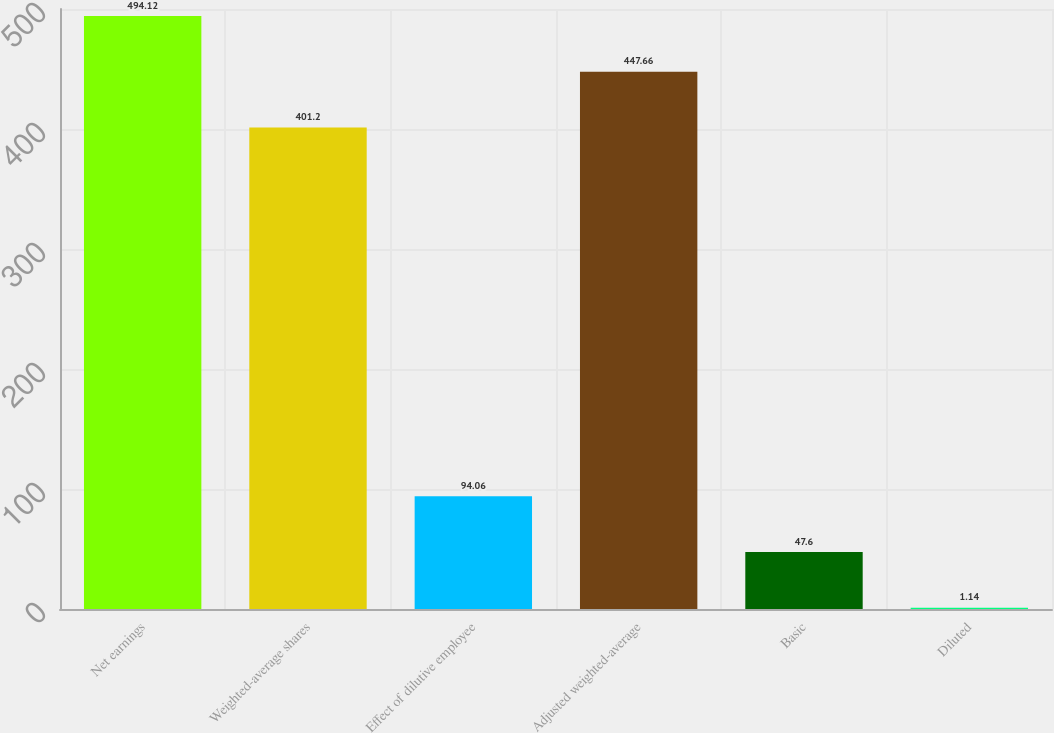<chart> <loc_0><loc_0><loc_500><loc_500><bar_chart><fcel>Net earnings<fcel>Weighted-average shares<fcel>Effect of dilutive employee<fcel>Adjusted weighted-average<fcel>Basic<fcel>Diluted<nl><fcel>494.12<fcel>401.2<fcel>94.06<fcel>447.66<fcel>47.6<fcel>1.14<nl></chart> 